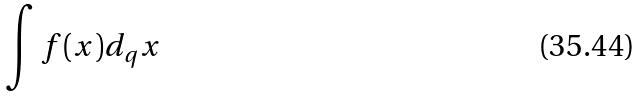<formula> <loc_0><loc_0><loc_500><loc_500>\int f ( x ) d _ { q } x</formula> 